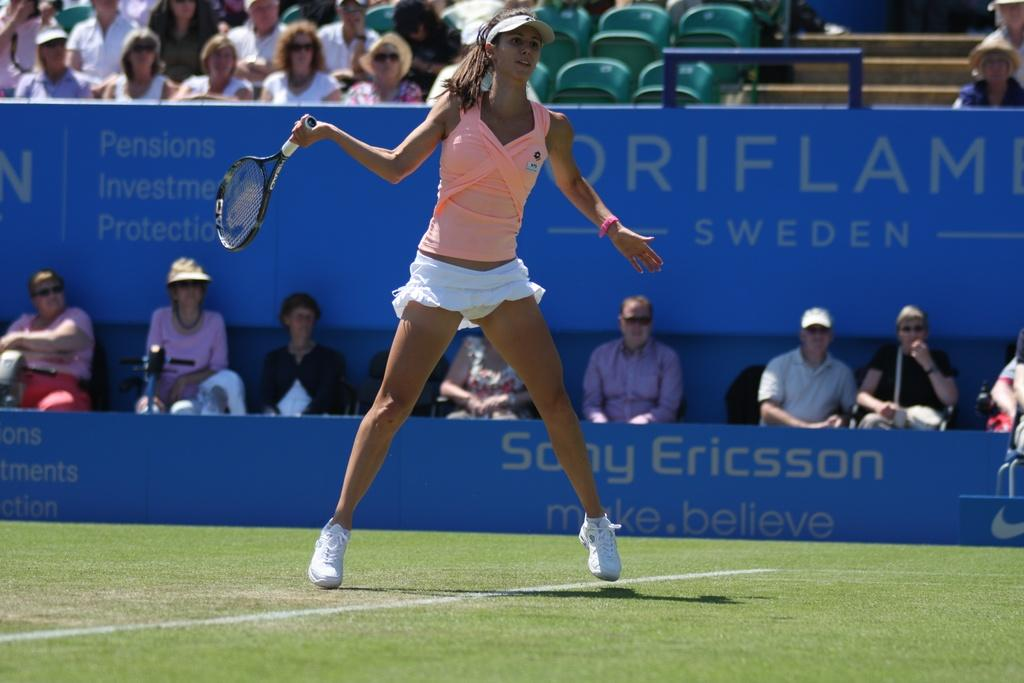What is the woman in the image holding? The woman is holding a racket in the image. Can you describe the woman's attire? The woman is wearing a hat in the image. What can be seen in the background of the image? There are people sitting on chairs in the background of the image. What color is the board in the image? There is a blue board in the image. What type of produce is being harvested in the image? There is no produce visible in the image; it features a woman holding a racket and a blue board. Can you see a stamp on the racket in the image? There is no stamp visible on the racket in the image. 